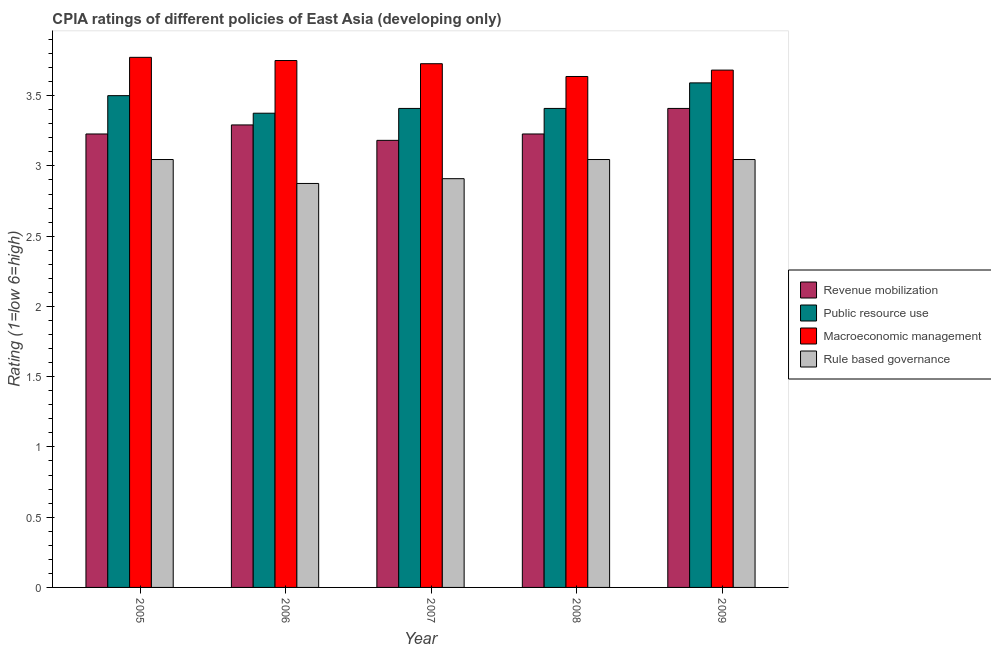How many groups of bars are there?
Offer a very short reply. 5. Are the number of bars per tick equal to the number of legend labels?
Offer a terse response. Yes. How many bars are there on the 4th tick from the right?
Your response must be concise. 4. What is the label of the 4th group of bars from the left?
Keep it short and to the point. 2008. In how many cases, is the number of bars for a given year not equal to the number of legend labels?
Provide a short and direct response. 0. What is the cpia rating of macroeconomic management in 2005?
Your response must be concise. 3.77. Across all years, what is the maximum cpia rating of public resource use?
Your answer should be compact. 3.59. Across all years, what is the minimum cpia rating of public resource use?
Give a very brief answer. 3.38. What is the total cpia rating of macroeconomic management in the graph?
Keep it short and to the point. 18.57. What is the difference between the cpia rating of macroeconomic management in 2007 and that in 2008?
Make the answer very short. 0.09. What is the difference between the cpia rating of macroeconomic management in 2008 and the cpia rating of public resource use in 2006?
Your answer should be very brief. -0.11. What is the average cpia rating of macroeconomic management per year?
Your answer should be very brief. 3.71. What is the ratio of the cpia rating of rule based governance in 2006 to that in 2008?
Your answer should be very brief. 0.94. Is the difference between the cpia rating of macroeconomic management in 2005 and 2006 greater than the difference between the cpia rating of rule based governance in 2005 and 2006?
Your response must be concise. No. What is the difference between the highest and the second highest cpia rating of rule based governance?
Your response must be concise. 0. What is the difference between the highest and the lowest cpia rating of revenue mobilization?
Offer a very short reply. 0.23. In how many years, is the cpia rating of public resource use greater than the average cpia rating of public resource use taken over all years?
Keep it short and to the point. 2. Is the sum of the cpia rating of revenue mobilization in 2008 and 2009 greater than the maximum cpia rating of rule based governance across all years?
Provide a short and direct response. Yes. What does the 4th bar from the left in 2009 represents?
Make the answer very short. Rule based governance. What does the 2nd bar from the right in 2009 represents?
Ensure brevity in your answer.  Macroeconomic management. Is it the case that in every year, the sum of the cpia rating of revenue mobilization and cpia rating of public resource use is greater than the cpia rating of macroeconomic management?
Give a very brief answer. Yes. Are the values on the major ticks of Y-axis written in scientific E-notation?
Your response must be concise. No. Does the graph contain any zero values?
Your answer should be very brief. No. Does the graph contain grids?
Your response must be concise. No. How many legend labels are there?
Keep it short and to the point. 4. What is the title of the graph?
Give a very brief answer. CPIA ratings of different policies of East Asia (developing only). What is the label or title of the X-axis?
Your response must be concise. Year. What is the label or title of the Y-axis?
Provide a succinct answer. Rating (1=low 6=high). What is the Rating (1=low 6=high) of Revenue mobilization in 2005?
Your answer should be very brief. 3.23. What is the Rating (1=low 6=high) of Macroeconomic management in 2005?
Provide a succinct answer. 3.77. What is the Rating (1=low 6=high) in Rule based governance in 2005?
Provide a short and direct response. 3.05. What is the Rating (1=low 6=high) in Revenue mobilization in 2006?
Offer a very short reply. 3.29. What is the Rating (1=low 6=high) of Public resource use in 2006?
Provide a short and direct response. 3.38. What is the Rating (1=low 6=high) in Macroeconomic management in 2006?
Your response must be concise. 3.75. What is the Rating (1=low 6=high) of Rule based governance in 2006?
Give a very brief answer. 2.88. What is the Rating (1=low 6=high) in Revenue mobilization in 2007?
Keep it short and to the point. 3.18. What is the Rating (1=low 6=high) of Public resource use in 2007?
Give a very brief answer. 3.41. What is the Rating (1=low 6=high) of Macroeconomic management in 2007?
Provide a succinct answer. 3.73. What is the Rating (1=low 6=high) in Rule based governance in 2007?
Provide a succinct answer. 2.91. What is the Rating (1=low 6=high) in Revenue mobilization in 2008?
Provide a short and direct response. 3.23. What is the Rating (1=low 6=high) of Public resource use in 2008?
Keep it short and to the point. 3.41. What is the Rating (1=low 6=high) in Macroeconomic management in 2008?
Ensure brevity in your answer.  3.64. What is the Rating (1=low 6=high) of Rule based governance in 2008?
Ensure brevity in your answer.  3.05. What is the Rating (1=low 6=high) of Revenue mobilization in 2009?
Your answer should be compact. 3.41. What is the Rating (1=low 6=high) of Public resource use in 2009?
Give a very brief answer. 3.59. What is the Rating (1=low 6=high) in Macroeconomic management in 2009?
Provide a succinct answer. 3.68. What is the Rating (1=low 6=high) in Rule based governance in 2009?
Ensure brevity in your answer.  3.05. Across all years, what is the maximum Rating (1=low 6=high) in Revenue mobilization?
Provide a short and direct response. 3.41. Across all years, what is the maximum Rating (1=low 6=high) of Public resource use?
Your response must be concise. 3.59. Across all years, what is the maximum Rating (1=low 6=high) of Macroeconomic management?
Provide a succinct answer. 3.77. Across all years, what is the maximum Rating (1=low 6=high) of Rule based governance?
Make the answer very short. 3.05. Across all years, what is the minimum Rating (1=low 6=high) in Revenue mobilization?
Ensure brevity in your answer.  3.18. Across all years, what is the minimum Rating (1=low 6=high) of Public resource use?
Ensure brevity in your answer.  3.38. Across all years, what is the minimum Rating (1=low 6=high) in Macroeconomic management?
Your answer should be very brief. 3.64. Across all years, what is the minimum Rating (1=low 6=high) in Rule based governance?
Make the answer very short. 2.88. What is the total Rating (1=low 6=high) of Revenue mobilization in the graph?
Provide a succinct answer. 16.34. What is the total Rating (1=low 6=high) in Public resource use in the graph?
Your response must be concise. 17.28. What is the total Rating (1=low 6=high) in Macroeconomic management in the graph?
Make the answer very short. 18.57. What is the total Rating (1=low 6=high) in Rule based governance in the graph?
Your answer should be compact. 14.92. What is the difference between the Rating (1=low 6=high) of Revenue mobilization in 2005 and that in 2006?
Ensure brevity in your answer.  -0.06. What is the difference between the Rating (1=low 6=high) of Public resource use in 2005 and that in 2006?
Your answer should be very brief. 0.12. What is the difference between the Rating (1=low 6=high) in Macroeconomic management in 2005 and that in 2006?
Keep it short and to the point. 0.02. What is the difference between the Rating (1=low 6=high) in Rule based governance in 2005 and that in 2006?
Your answer should be very brief. 0.17. What is the difference between the Rating (1=low 6=high) in Revenue mobilization in 2005 and that in 2007?
Make the answer very short. 0.05. What is the difference between the Rating (1=low 6=high) in Public resource use in 2005 and that in 2007?
Provide a succinct answer. 0.09. What is the difference between the Rating (1=low 6=high) of Macroeconomic management in 2005 and that in 2007?
Provide a succinct answer. 0.05. What is the difference between the Rating (1=low 6=high) in Rule based governance in 2005 and that in 2007?
Ensure brevity in your answer.  0.14. What is the difference between the Rating (1=low 6=high) of Public resource use in 2005 and that in 2008?
Keep it short and to the point. 0.09. What is the difference between the Rating (1=low 6=high) in Macroeconomic management in 2005 and that in 2008?
Ensure brevity in your answer.  0.14. What is the difference between the Rating (1=low 6=high) of Revenue mobilization in 2005 and that in 2009?
Offer a terse response. -0.18. What is the difference between the Rating (1=low 6=high) in Public resource use in 2005 and that in 2009?
Offer a very short reply. -0.09. What is the difference between the Rating (1=low 6=high) in Macroeconomic management in 2005 and that in 2009?
Offer a terse response. 0.09. What is the difference between the Rating (1=low 6=high) in Revenue mobilization in 2006 and that in 2007?
Your response must be concise. 0.11. What is the difference between the Rating (1=low 6=high) of Public resource use in 2006 and that in 2007?
Your answer should be compact. -0.03. What is the difference between the Rating (1=low 6=high) of Macroeconomic management in 2006 and that in 2007?
Your response must be concise. 0.02. What is the difference between the Rating (1=low 6=high) in Rule based governance in 2006 and that in 2007?
Offer a very short reply. -0.03. What is the difference between the Rating (1=low 6=high) in Revenue mobilization in 2006 and that in 2008?
Provide a short and direct response. 0.06. What is the difference between the Rating (1=low 6=high) in Public resource use in 2006 and that in 2008?
Your response must be concise. -0.03. What is the difference between the Rating (1=low 6=high) of Macroeconomic management in 2006 and that in 2008?
Your response must be concise. 0.11. What is the difference between the Rating (1=low 6=high) of Rule based governance in 2006 and that in 2008?
Ensure brevity in your answer.  -0.17. What is the difference between the Rating (1=low 6=high) of Revenue mobilization in 2006 and that in 2009?
Provide a succinct answer. -0.12. What is the difference between the Rating (1=low 6=high) in Public resource use in 2006 and that in 2009?
Offer a terse response. -0.22. What is the difference between the Rating (1=low 6=high) of Macroeconomic management in 2006 and that in 2009?
Your answer should be compact. 0.07. What is the difference between the Rating (1=low 6=high) in Rule based governance in 2006 and that in 2009?
Make the answer very short. -0.17. What is the difference between the Rating (1=low 6=high) of Revenue mobilization in 2007 and that in 2008?
Make the answer very short. -0.05. What is the difference between the Rating (1=low 6=high) of Public resource use in 2007 and that in 2008?
Offer a terse response. 0. What is the difference between the Rating (1=low 6=high) of Macroeconomic management in 2007 and that in 2008?
Provide a succinct answer. 0.09. What is the difference between the Rating (1=low 6=high) in Rule based governance in 2007 and that in 2008?
Your answer should be very brief. -0.14. What is the difference between the Rating (1=low 6=high) in Revenue mobilization in 2007 and that in 2009?
Provide a succinct answer. -0.23. What is the difference between the Rating (1=low 6=high) in Public resource use in 2007 and that in 2009?
Ensure brevity in your answer.  -0.18. What is the difference between the Rating (1=low 6=high) of Macroeconomic management in 2007 and that in 2009?
Provide a short and direct response. 0.05. What is the difference between the Rating (1=low 6=high) of Rule based governance in 2007 and that in 2009?
Your answer should be very brief. -0.14. What is the difference between the Rating (1=low 6=high) in Revenue mobilization in 2008 and that in 2009?
Ensure brevity in your answer.  -0.18. What is the difference between the Rating (1=low 6=high) in Public resource use in 2008 and that in 2009?
Keep it short and to the point. -0.18. What is the difference between the Rating (1=low 6=high) in Macroeconomic management in 2008 and that in 2009?
Ensure brevity in your answer.  -0.05. What is the difference between the Rating (1=low 6=high) of Revenue mobilization in 2005 and the Rating (1=low 6=high) of Public resource use in 2006?
Ensure brevity in your answer.  -0.15. What is the difference between the Rating (1=low 6=high) of Revenue mobilization in 2005 and the Rating (1=low 6=high) of Macroeconomic management in 2006?
Make the answer very short. -0.52. What is the difference between the Rating (1=low 6=high) of Revenue mobilization in 2005 and the Rating (1=low 6=high) of Rule based governance in 2006?
Keep it short and to the point. 0.35. What is the difference between the Rating (1=low 6=high) in Public resource use in 2005 and the Rating (1=low 6=high) in Macroeconomic management in 2006?
Provide a short and direct response. -0.25. What is the difference between the Rating (1=low 6=high) in Public resource use in 2005 and the Rating (1=low 6=high) in Rule based governance in 2006?
Give a very brief answer. 0.62. What is the difference between the Rating (1=low 6=high) in Macroeconomic management in 2005 and the Rating (1=low 6=high) in Rule based governance in 2006?
Ensure brevity in your answer.  0.9. What is the difference between the Rating (1=low 6=high) of Revenue mobilization in 2005 and the Rating (1=low 6=high) of Public resource use in 2007?
Your answer should be compact. -0.18. What is the difference between the Rating (1=low 6=high) in Revenue mobilization in 2005 and the Rating (1=low 6=high) in Rule based governance in 2007?
Your response must be concise. 0.32. What is the difference between the Rating (1=low 6=high) of Public resource use in 2005 and the Rating (1=low 6=high) of Macroeconomic management in 2007?
Offer a very short reply. -0.23. What is the difference between the Rating (1=low 6=high) in Public resource use in 2005 and the Rating (1=low 6=high) in Rule based governance in 2007?
Offer a terse response. 0.59. What is the difference between the Rating (1=low 6=high) in Macroeconomic management in 2005 and the Rating (1=low 6=high) in Rule based governance in 2007?
Your response must be concise. 0.86. What is the difference between the Rating (1=low 6=high) in Revenue mobilization in 2005 and the Rating (1=low 6=high) in Public resource use in 2008?
Provide a short and direct response. -0.18. What is the difference between the Rating (1=low 6=high) of Revenue mobilization in 2005 and the Rating (1=low 6=high) of Macroeconomic management in 2008?
Provide a succinct answer. -0.41. What is the difference between the Rating (1=low 6=high) of Revenue mobilization in 2005 and the Rating (1=low 6=high) of Rule based governance in 2008?
Your answer should be very brief. 0.18. What is the difference between the Rating (1=low 6=high) in Public resource use in 2005 and the Rating (1=low 6=high) in Macroeconomic management in 2008?
Your answer should be compact. -0.14. What is the difference between the Rating (1=low 6=high) in Public resource use in 2005 and the Rating (1=low 6=high) in Rule based governance in 2008?
Give a very brief answer. 0.45. What is the difference between the Rating (1=low 6=high) in Macroeconomic management in 2005 and the Rating (1=low 6=high) in Rule based governance in 2008?
Offer a terse response. 0.73. What is the difference between the Rating (1=low 6=high) of Revenue mobilization in 2005 and the Rating (1=low 6=high) of Public resource use in 2009?
Ensure brevity in your answer.  -0.36. What is the difference between the Rating (1=low 6=high) of Revenue mobilization in 2005 and the Rating (1=low 6=high) of Macroeconomic management in 2009?
Make the answer very short. -0.45. What is the difference between the Rating (1=low 6=high) of Revenue mobilization in 2005 and the Rating (1=low 6=high) of Rule based governance in 2009?
Offer a terse response. 0.18. What is the difference between the Rating (1=low 6=high) in Public resource use in 2005 and the Rating (1=low 6=high) in Macroeconomic management in 2009?
Ensure brevity in your answer.  -0.18. What is the difference between the Rating (1=low 6=high) in Public resource use in 2005 and the Rating (1=low 6=high) in Rule based governance in 2009?
Keep it short and to the point. 0.45. What is the difference between the Rating (1=low 6=high) in Macroeconomic management in 2005 and the Rating (1=low 6=high) in Rule based governance in 2009?
Provide a short and direct response. 0.73. What is the difference between the Rating (1=low 6=high) in Revenue mobilization in 2006 and the Rating (1=low 6=high) in Public resource use in 2007?
Keep it short and to the point. -0.12. What is the difference between the Rating (1=low 6=high) in Revenue mobilization in 2006 and the Rating (1=low 6=high) in Macroeconomic management in 2007?
Your answer should be very brief. -0.44. What is the difference between the Rating (1=low 6=high) of Revenue mobilization in 2006 and the Rating (1=low 6=high) of Rule based governance in 2007?
Ensure brevity in your answer.  0.38. What is the difference between the Rating (1=low 6=high) in Public resource use in 2006 and the Rating (1=low 6=high) in Macroeconomic management in 2007?
Offer a very short reply. -0.35. What is the difference between the Rating (1=low 6=high) in Public resource use in 2006 and the Rating (1=low 6=high) in Rule based governance in 2007?
Provide a short and direct response. 0.47. What is the difference between the Rating (1=low 6=high) in Macroeconomic management in 2006 and the Rating (1=low 6=high) in Rule based governance in 2007?
Offer a terse response. 0.84. What is the difference between the Rating (1=low 6=high) in Revenue mobilization in 2006 and the Rating (1=low 6=high) in Public resource use in 2008?
Give a very brief answer. -0.12. What is the difference between the Rating (1=low 6=high) in Revenue mobilization in 2006 and the Rating (1=low 6=high) in Macroeconomic management in 2008?
Ensure brevity in your answer.  -0.34. What is the difference between the Rating (1=low 6=high) of Revenue mobilization in 2006 and the Rating (1=low 6=high) of Rule based governance in 2008?
Make the answer very short. 0.25. What is the difference between the Rating (1=low 6=high) of Public resource use in 2006 and the Rating (1=low 6=high) of Macroeconomic management in 2008?
Provide a succinct answer. -0.26. What is the difference between the Rating (1=low 6=high) of Public resource use in 2006 and the Rating (1=low 6=high) of Rule based governance in 2008?
Your answer should be very brief. 0.33. What is the difference between the Rating (1=low 6=high) of Macroeconomic management in 2006 and the Rating (1=low 6=high) of Rule based governance in 2008?
Your response must be concise. 0.7. What is the difference between the Rating (1=low 6=high) of Revenue mobilization in 2006 and the Rating (1=low 6=high) of Public resource use in 2009?
Your answer should be compact. -0.3. What is the difference between the Rating (1=low 6=high) of Revenue mobilization in 2006 and the Rating (1=low 6=high) of Macroeconomic management in 2009?
Make the answer very short. -0.39. What is the difference between the Rating (1=low 6=high) of Revenue mobilization in 2006 and the Rating (1=low 6=high) of Rule based governance in 2009?
Offer a terse response. 0.25. What is the difference between the Rating (1=low 6=high) of Public resource use in 2006 and the Rating (1=low 6=high) of Macroeconomic management in 2009?
Offer a very short reply. -0.31. What is the difference between the Rating (1=low 6=high) of Public resource use in 2006 and the Rating (1=low 6=high) of Rule based governance in 2009?
Make the answer very short. 0.33. What is the difference between the Rating (1=low 6=high) in Macroeconomic management in 2006 and the Rating (1=low 6=high) in Rule based governance in 2009?
Make the answer very short. 0.7. What is the difference between the Rating (1=low 6=high) of Revenue mobilization in 2007 and the Rating (1=low 6=high) of Public resource use in 2008?
Offer a very short reply. -0.23. What is the difference between the Rating (1=low 6=high) in Revenue mobilization in 2007 and the Rating (1=low 6=high) in Macroeconomic management in 2008?
Give a very brief answer. -0.45. What is the difference between the Rating (1=low 6=high) of Revenue mobilization in 2007 and the Rating (1=low 6=high) of Rule based governance in 2008?
Your answer should be compact. 0.14. What is the difference between the Rating (1=low 6=high) in Public resource use in 2007 and the Rating (1=low 6=high) in Macroeconomic management in 2008?
Offer a very short reply. -0.23. What is the difference between the Rating (1=low 6=high) in Public resource use in 2007 and the Rating (1=low 6=high) in Rule based governance in 2008?
Ensure brevity in your answer.  0.36. What is the difference between the Rating (1=low 6=high) of Macroeconomic management in 2007 and the Rating (1=low 6=high) of Rule based governance in 2008?
Ensure brevity in your answer.  0.68. What is the difference between the Rating (1=low 6=high) of Revenue mobilization in 2007 and the Rating (1=low 6=high) of Public resource use in 2009?
Offer a terse response. -0.41. What is the difference between the Rating (1=low 6=high) of Revenue mobilization in 2007 and the Rating (1=low 6=high) of Rule based governance in 2009?
Keep it short and to the point. 0.14. What is the difference between the Rating (1=low 6=high) in Public resource use in 2007 and the Rating (1=low 6=high) in Macroeconomic management in 2009?
Keep it short and to the point. -0.27. What is the difference between the Rating (1=low 6=high) in Public resource use in 2007 and the Rating (1=low 6=high) in Rule based governance in 2009?
Provide a succinct answer. 0.36. What is the difference between the Rating (1=low 6=high) in Macroeconomic management in 2007 and the Rating (1=low 6=high) in Rule based governance in 2009?
Offer a very short reply. 0.68. What is the difference between the Rating (1=low 6=high) of Revenue mobilization in 2008 and the Rating (1=low 6=high) of Public resource use in 2009?
Provide a succinct answer. -0.36. What is the difference between the Rating (1=low 6=high) of Revenue mobilization in 2008 and the Rating (1=low 6=high) of Macroeconomic management in 2009?
Keep it short and to the point. -0.45. What is the difference between the Rating (1=low 6=high) of Revenue mobilization in 2008 and the Rating (1=low 6=high) of Rule based governance in 2009?
Offer a terse response. 0.18. What is the difference between the Rating (1=low 6=high) of Public resource use in 2008 and the Rating (1=low 6=high) of Macroeconomic management in 2009?
Your response must be concise. -0.27. What is the difference between the Rating (1=low 6=high) in Public resource use in 2008 and the Rating (1=low 6=high) in Rule based governance in 2009?
Give a very brief answer. 0.36. What is the difference between the Rating (1=low 6=high) in Macroeconomic management in 2008 and the Rating (1=low 6=high) in Rule based governance in 2009?
Your answer should be compact. 0.59. What is the average Rating (1=low 6=high) of Revenue mobilization per year?
Give a very brief answer. 3.27. What is the average Rating (1=low 6=high) in Public resource use per year?
Ensure brevity in your answer.  3.46. What is the average Rating (1=low 6=high) in Macroeconomic management per year?
Provide a short and direct response. 3.71. What is the average Rating (1=low 6=high) of Rule based governance per year?
Provide a short and direct response. 2.98. In the year 2005, what is the difference between the Rating (1=low 6=high) in Revenue mobilization and Rating (1=low 6=high) in Public resource use?
Your answer should be compact. -0.27. In the year 2005, what is the difference between the Rating (1=low 6=high) in Revenue mobilization and Rating (1=low 6=high) in Macroeconomic management?
Offer a very short reply. -0.55. In the year 2005, what is the difference between the Rating (1=low 6=high) of Revenue mobilization and Rating (1=low 6=high) of Rule based governance?
Your answer should be compact. 0.18. In the year 2005, what is the difference between the Rating (1=low 6=high) of Public resource use and Rating (1=low 6=high) of Macroeconomic management?
Your response must be concise. -0.27. In the year 2005, what is the difference between the Rating (1=low 6=high) of Public resource use and Rating (1=low 6=high) of Rule based governance?
Keep it short and to the point. 0.45. In the year 2005, what is the difference between the Rating (1=low 6=high) in Macroeconomic management and Rating (1=low 6=high) in Rule based governance?
Offer a terse response. 0.73. In the year 2006, what is the difference between the Rating (1=low 6=high) in Revenue mobilization and Rating (1=low 6=high) in Public resource use?
Provide a succinct answer. -0.08. In the year 2006, what is the difference between the Rating (1=low 6=high) of Revenue mobilization and Rating (1=low 6=high) of Macroeconomic management?
Make the answer very short. -0.46. In the year 2006, what is the difference between the Rating (1=low 6=high) of Revenue mobilization and Rating (1=low 6=high) of Rule based governance?
Your response must be concise. 0.42. In the year 2006, what is the difference between the Rating (1=low 6=high) of Public resource use and Rating (1=low 6=high) of Macroeconomic management?
Your answer should be very brief. -0.38. In the year 2006, what is the difference between the Rating (1=low 6=high) of Macroeconomic management and Rating (1=low 6=high) of Rule based governance?
Your answer should be compact. 0.88. In the year 2007, what is the difference between the Rating (1=low 6=high) in Revenue mobilization and Rating (1=low 6=high) in Public resource use?
Your response must be concise. -0.23. In the year 2007, what is the difference between the Rating (1=low 6=high) in Revenue mobilization and Rating (1=low 6=high) in Macroeconomic management?
Offer a terse response. -0.55. In the year 2007, what is the difference between the Rating (1=low 6=high) in Revenue mobilization and Rating (1=low 6=high) in Rule based governance?
Your answer should be compact. 0.27. In the year 2007, what is the difference between the Rating (1=low 6=high) in Public resource use and Rating (1=low 6=high) in Macroeconomic management?
Your answer should be very brief. -0.32. In the year 2007, what is the difference between the Rating (1=low 6=high) of Public resource use and Rating (1=low 6=high) of Rule based governance?
Offer a terse response. 0.5. In the year 2007, what is the difference between the Rating (1=low 6=high) in Macroeconomic management and Rating (1=low 6=high) in Rule based governance?
Offer a very short reply. 0.82. In the year 2008, what is the difference between the Rating (1=low 6=high) of Revenue mobilization and Rating (1=low 6=high) of Public resource use?
Make the answer very short. -0.18. In the year 2008, what is the difference between the Rating (1=low 6=high) in Revenue mobilization and Rating (1=low 6=high) in Macroeconomic management?
Offer a very short reply. -0.41. In the year 2008, what is the difference between the Rating (1=low 6=high) of Revenue mobilization and Rating (1=low 6=high) of Rule based governance?
Your answer should be compact. 0.18. In the year 2008, what is the difference between the Rating (1=low 6=high) in Public resource use and Rating (1=low 6=high) in Macroeconomic management?
Your answer should be compact. -0.23. In the year 2008, what is the difference between the Rating (1=low 6=high) of Public resource use and Rating (1=low 6=high) of Rule based governance?
Your answer should be compact. 0.36. In the year 2008, what is the difference between the Rating (1=low 6=high) in Macroeconomic management and Rating (1=low 6=high) in Rule based governance?
Offer a very short reply. 0.59. In the year 2009, what is the difference between the Rating (1=low 6=high) of Revenue mobilization and Rating (1=low 6=high) of Public resource use?
Keep it short and to the point. -0.18. In the year 2009, what is the difference between the Rating (1=low 6=high) in Revenue mobilization and Rating (1=low 6=high) in Macroeconomic management?
Keep it short and to the point. -0.27. In the year 2009, what is the difference between the Rating (1=low 6=high) in Revenue mobilization and Rating (1=low 6=high) in Rule based governance?
Provide a succinct answer. 0.36. In the year 2009, what is the difference between the Rating (1=low 6=high) of Public resource use and Rating (1=low 6=high) of Macroeconomic management?
Keep it short and to the point. -0.09. In the year 2009, what is the difference between the Rating (1=low 6=high) in Public resource use and Rating (1=low 6=high) in Rule based governance?
Give a very brief answer. 0.55. In the year 2009, what is the difference between the Rating (1=low 6=high) in Macroeconomic management and Rating (1=low 6=high) in Rule based governance?
Keep it short and to the point. 0.64. What is the ratio of the Rating (1=low 6=high) in Revenue mobilization in 2005 to that in 2006?
Your answer should be compact. 0.98. What is the ratio of the Rating (1=low 6=high) in Public resource use in 2005 to that in 2006?
Provide a succinct answer. 1.04. What is the ratio of the Rating (1=low 6=high) of Rule based governance in 2005 to that in 2006?
Make the answer very short. 1.06. What is the ratio of the Rating (1=low 6=high) of Revenue mobilization in 2005 to that in 2007?
Make the answer very short. 1.01. What is the ratio of the Rating (1=low 6=high) in Public resource use in 2005 to that in 2007?
Offer a terse response. 1.03. What is the ratio of the Rating (1=low 6=high) of Macroeconomic management in 2005 to that in 2007?
Your answer should be compact. 1.01. What is the ratio of the Rating (1=low 6=high) of Rule based governance in 2005 to that in 2007?
Offer a terse response. 1.05. What is the ratio of the Rating (1=low 6=high) of Revenue mobilization in 2005 to that in 2008?
Offer a terse response. 1. What is the ratio of the Rating (1=low 6=high) in Public resource use in 2005 to that in 2008?
Provide a short and direct response. 1.03. What is the ratio of the Rating (1=low 6=high) of Macroeconomic management in 2005 to that in 2008?
Your answer should be very brief. 1.04. What is the ratio of the Rating (1=low 6=high) in Rule based governance in 2005 to that in 2008?
Offer a terse response. 1. What is the ratio of the Rating (1=low 6=high) in Revenue mobilization in 2005 to that in 2009?
Provide a succinct answer. 0.95. What is the ratio of the Rating (1=low 6=high) in Public resource use in 2005 to that in 2009?
Provide a short and direct response. 0.97. What is the ratio of the Rating (1=low 6=high) of Macroeconomic management in 2005 to that in 2009?
Provide a succinct answer. 1.02. What is the ratio of the Rating (1=low 6=high) in Revenue mobilization in 2006 to that in 2007?
Offer a very short reply. 1.03. What is the ratio of the Rating (1=low 6=high) of Public resource use in 2006 to that in 2007?
Provide a short and direct response. 0.99. What is the ratio of the Rating (1=low 6=high) in Rule based governance in 2006 to that in 2007?
Keep it short and to the point. 0.99. What is the ratio of the Rating (1=low 6=high) of Revenue mobilization in 2006 to that in 2008?
Provide a succinct answer. 1.02. What is the ratio of the Rating (1=low 6=high) in Public resource use in 2006 to that in 2008?
Give a very brief answer. 0.99. What is the ratio of the Rating (1=low 6=high) in Macroeconomic management in 2006 to that in 2008?
Offer a terse response. 1.03. What is the ratio of the Rating (1=low 6=high) in Rule based governance in 2006 to that in 2008?
Your response must be concise. 0.94. What is the ratio of the Rating (1=low 6=high) in Revenue mobilization in 2006 to that in 2009?
Offer a very short reply. 0.97. What is the ratio of the Rating (1=low 6=high) in Public resource use in 2006 to that in 2009?
Provide a succinct answer. 0.94. What is the ratio of the Rating (1=low 6=high) of Macroeconomic management in 2006 to that in 2009?
Offer a very short reply. 1.02. What is the ratio of the Rating (1=low 6=high) of Rule based governance in 2006 to that in 2009?
Provide a short and direct response. 0.94. What is the ratio of the Rating (1=low 6=high) of Revenue mobilization in 2007 to that in 2008?
Your response must be concise. 0.99. What is the ratio of the Rating (1=low 6=high) in Public resource use in 2007 to that in 2008?
Ensure brevity in your answer.  1. What is the ratio of the Rating (1=low 6=high) of Rule based governance in 2007 to that in 2008?
Your answer should be very brief. 0.96. What is the ratio of the Rating (1=low 6=high) in Public resource use in 2007 to that in 2009?
Your response must be concise. 0.95. What is the ratio of the Rating (1=low 6=high) in Macroeconomic management in 2007 to that in 2009?
Give a very brief answer. 1.01. What is the ratio of the Rating (1=low 6=high) of Rule based governance in 2007 to that in 2009?
Your answer should be compact. 0.96. What is the ratio of the Rating (1=low 6=high) in Revenue mobilization in 2008 to that in 2009?
Your answer should be very brief. 0.95. What is the ratio of the Rating (1=low 6=high) in Public resource use in 2008 to that in 2009?
Offer a terse response. 0.95. What is the ratio of the Rating (1=low 6=high) of Rule based governance in 2008 to that in 2009?
Give a very brief answer. 1. What is the difference between the highest and the second highest Rating (1=low 6=high) in Revenue mobilization?
Ensure brevity in your answer.  0.12. What is the difference between the highest and the second highest Rating (1=low 6=high) in Public resource use?
Ensure brevity in your answer.  0.09. What is the difference between the highest and the second highest Rating (1=low 6=high) in Macroeconomic management?
Your answer should be very brief. 0.02. What is the difference between the highest and the second highest Rating (1=low 6=high) in Rule based governance?
Keep it short and to the point. 0. What is the difference between the highest and the lowest Rating (1=low 6=high) in Revenue mobilization?
Your response must be concise. 0.23. What is the difference between the highest and the lowest Rating (1=low 6=high) in Public resource use?
Provide a succinct answer. 0.22. What is the difference between the highest and the lowest Rating (1=low 6=high) of Macroeconomic management?
Offer a terse response. 0.14. What is the difference between the highest and the lowest Rating (1=low 6=high) of Rule based governance?
Keep it short and to the point. 0.17. 